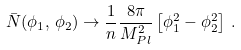Convert formula to latex. <formula><loc_0><loc_0><loc_500><loc_500>\bar { N } ( \phi _ { 1 } , \, \phi _ { 2 } ) \rightarrow \frac { 1 } { n } \frac { 8 \pi } { M ^ { 2 } _ { P l } } \left [ \phi ^ { 2 } _ { 1 } - \phi ^ { 2 } _ { 2 } \right ] \, .</formula> 